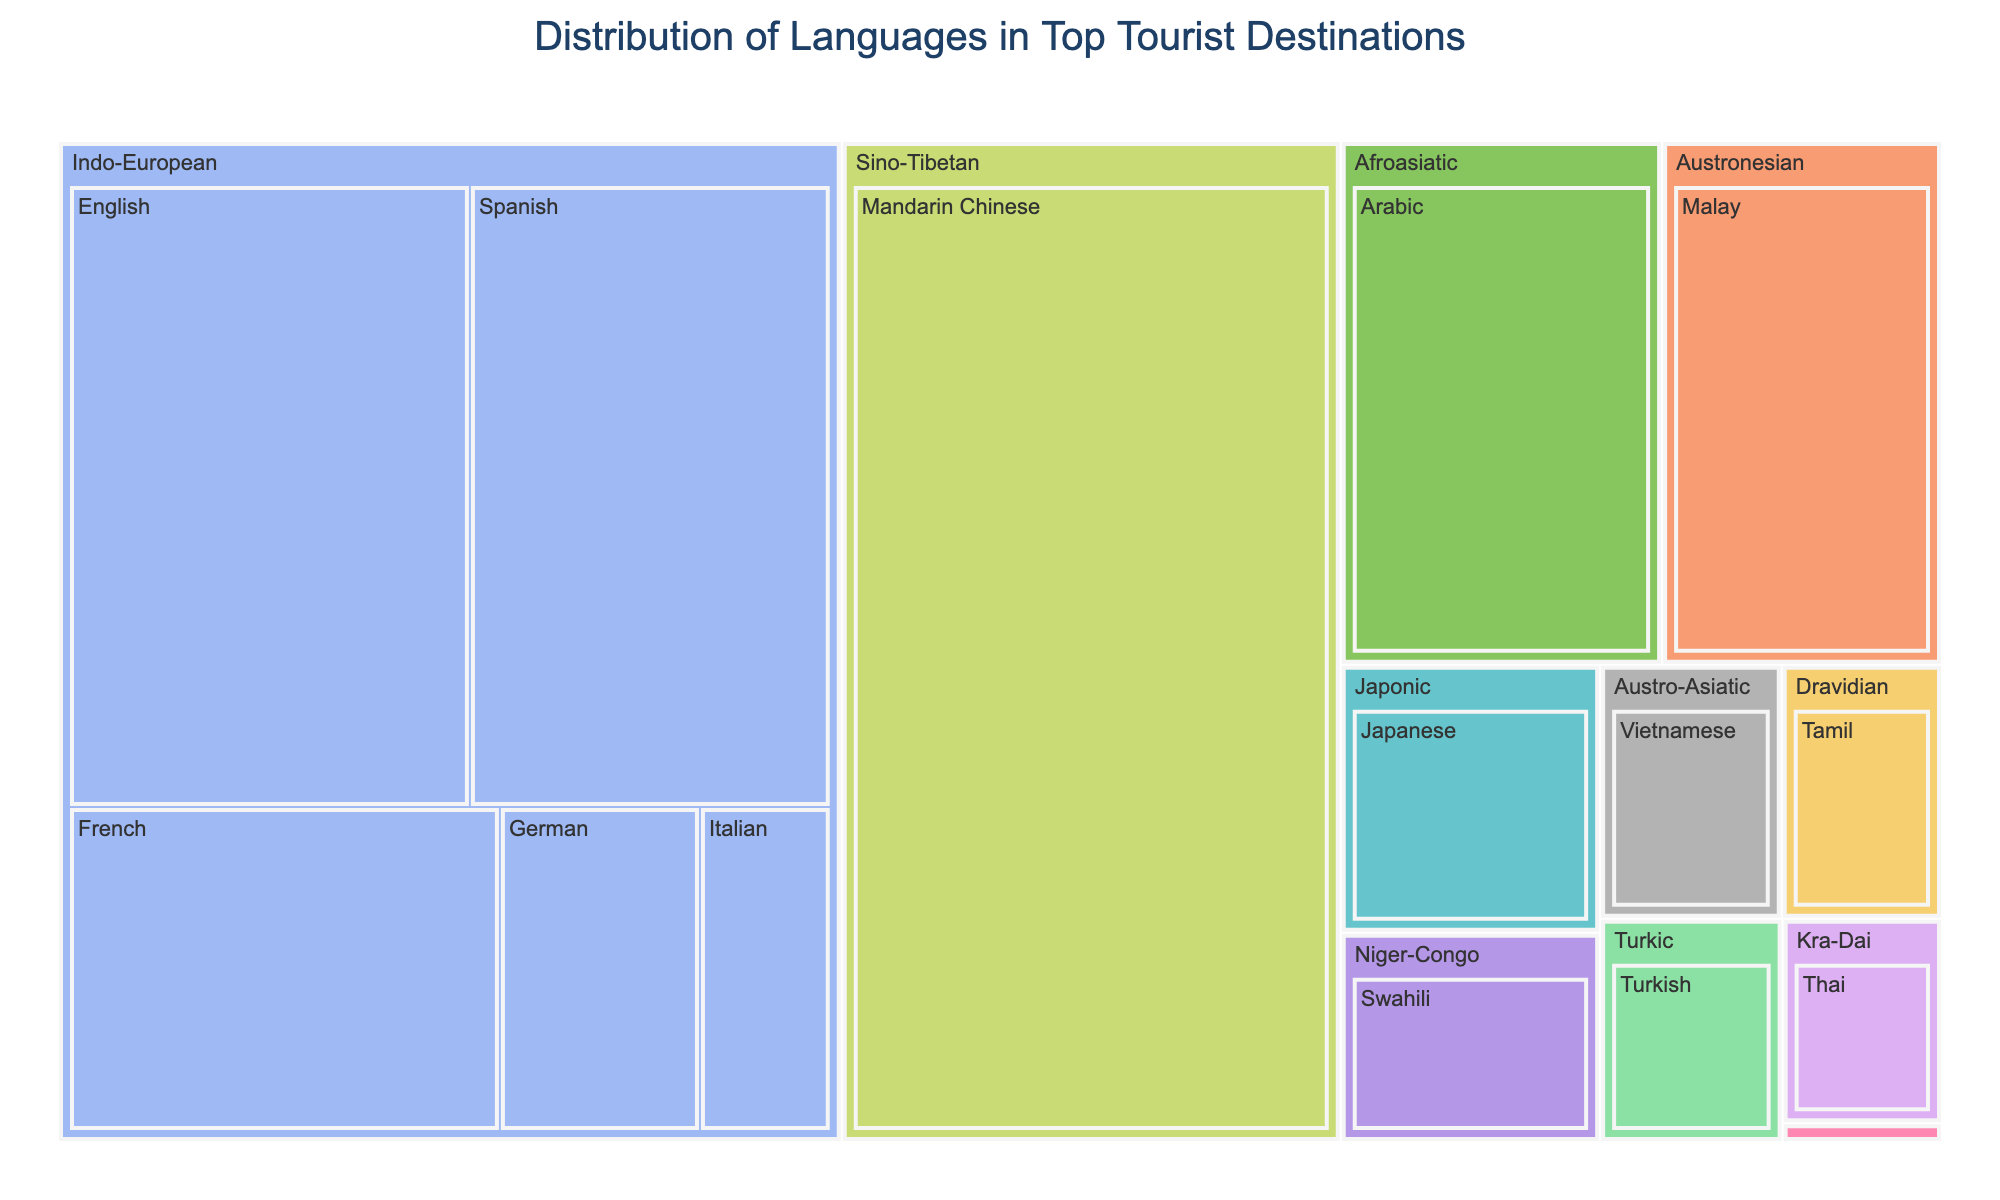What's the title of the treemap? The title is typically placed at the top center of the plot. In this case, the title is clearly stated at the top.
Answer: Distribution of Languages in Top Tourist Destinations Which language has the most speakers? By looking at the size of the segments in the treemap, the largest segment represents the language with the most speakers. Mandarin Chinese has the largest segment.
Answer: Mandarin Chinese How many language families are represented in the treemap? Each unique color in the treemap represents a different language family. By counting the number of different colors, we can see there are 10 language families represented.
Answer: 10 What is the total number of speakers in the Indo-European language family? To find the total number of speakers, sum the number of speakers for each language in the Indo-European family: English (500M) + Spanish (450M) + French (280M) + German (130M) + Italian (85M). Therefore, the total is 1445 million.
Answer: 1445 million Which language has more speakers: Arabic or Swahili? Compare the size of the segments for Arabic and Swahili. Based on the plot, Arabic has 310 million speakers, while Swahili has 100 million speakers.
Answer: Arabic Which language family contains the least number of speakers? Find the smallest segment group by totaling each family. The Uralic family has only Finnish with 5.5 million speakers.
Answer: Uralic What is the average number of speakers for the languages in the Austro-Asiatic family? The Austro-Asiatic family has only Vietnamese with 85 million speakers. The average is calculated as the total number divided by the number of languages in the family, which is 85M/1.
Answer: 85 million Between Japanese and Turkish, which language has fewer speakers and by how much? Compare the segments for Japanese (128M) and Turkish (75M). Subtract the smaller number from the larger: 128M - 75M = 53M.
Answer: Turkish by 53 million How do the segments for Thai and Italian compare in terms of relative size? Look at the segments for Thai (60M) and Italian (85M). Thai's segment is smaller than Italian's segment.
Answer: Thai is smaller Which language families lie between the Sino-Tibetan and Kra-Dai families? Judging by the order in the hierarchy of the plot, the language family that lies between them typically sits physically between the two segments.
Answer: Afroasiatic, Austronesian 